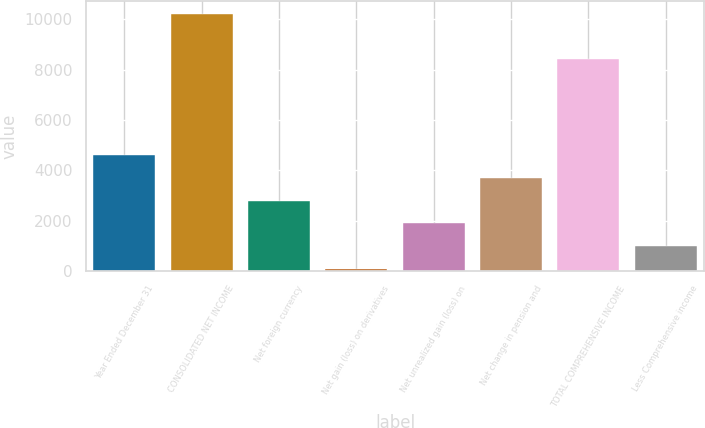Convert chart. <chart><loc_0><loc_0><loc_500><loc_500><bar_chart><fcel>Year Ended December 31<fcel>CONSOLIDATED NET INCOME<fcel>Net foreign currency<fcel>Net gain (loss) on derivatives<fcel>Net unrealized gain (loss) on<fcel>Net change in pension and<fcel>TOTAL COMPREHENSIVE INCOME<fcel>Less Comprehensive income<nl><fcel>4592.5<fcel>10205.4<fcel>2795.1<fcel>99<fcel>1896.4<fcel>3693.8<fcel>8408<fcel>997.7<nl></chart> 